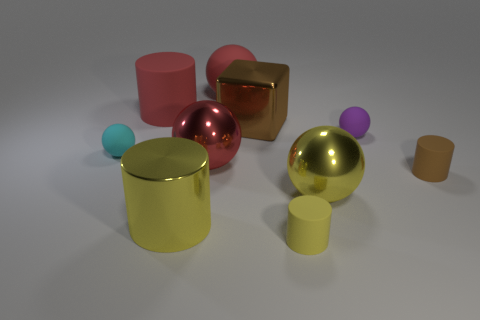Subtract all purple balls. How many balls are left? 4 Subtract 1 balls. How many balls are left? 4 Subtract all cyan matte balls. How many balls are left? 4 Subtract all brown balls. Subtract all green cylinders. How many balls are left? 5 Subtract all cubes. How many objects are left? 9 Add 8 big matte spheres. How many big matte spheres are left? 9 Add 5 cylinders. How many cylinders exist? 9 Subtract 0 blue spheres. How many objects are left? 10 Subtract all large cylinders. Subtract all tiny spheres. How many objects are left? 6 